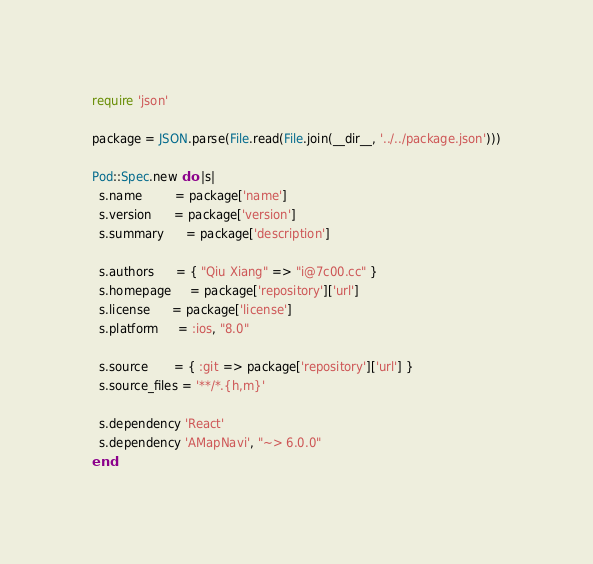Convert code to text. <code><loc_0><loc_0><loc_500><loc_500><_Ruby_>require 'json'

package = JSON.parse(File.read(File.join(__dir__, '../../package.json')))

Pod::Spec.new do |s|
  s.name         = package['name']
  s.version      = package['version']
  s.summary      = package['description']

  s.authors      = { "Qiu Xiang" => "i@7c00.cc" }
  s.homepage     = package['repository']['url']
  s.license      = package['license']
  s.platform     = :ios, "8.0"

  s.source       = { :git => package['repository']['url'] }
  s.source_files = '**/*.{h,m}'

  s.dependency 'React'
  s.dependency 'AMapNavi', "~> 6.0.0"
end
</code> 